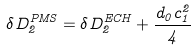Convert formula to latex. <formula><loc_0><loc_0><loc_500><loc_500>\delta D _ { 2 } ^ { P M S } = \delta D _ { 2 } ^ { E C H } + \frac { d _ { 0 } c _ { 1 } ^ { 2 } } { 4 }</formula> 